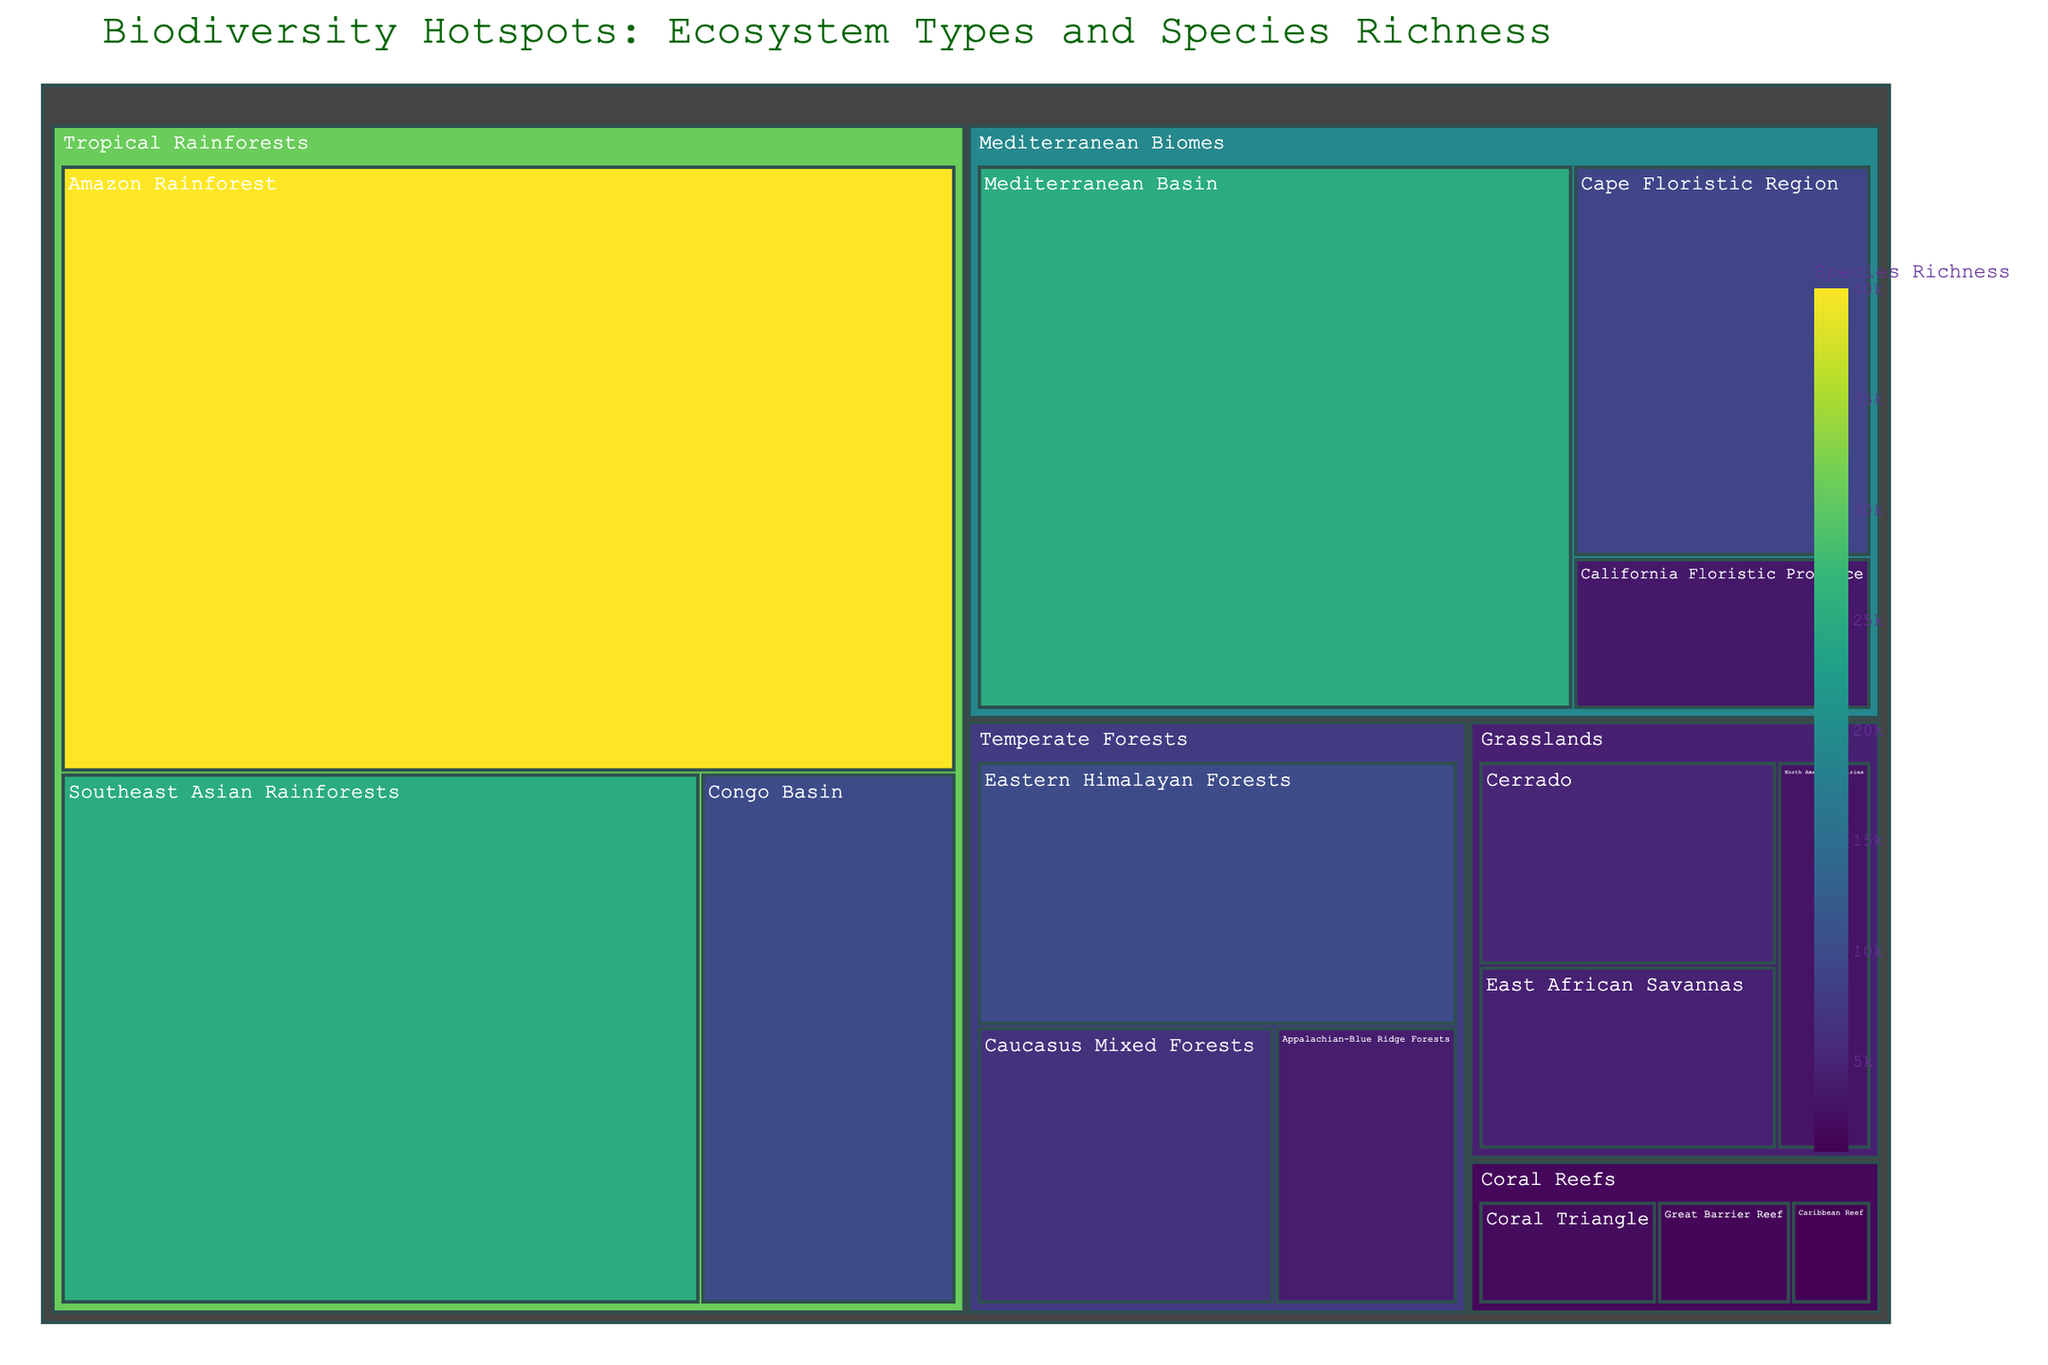Which ecosystem type has the highest species richness? By looking at the treemap, find the largest box under the "ecosystem" categories. The "Tropical Rainforests" category includes the Amazon Rainforest with 40,000 species of richness, the highest value for any ecosystem type.
Answer: Tropical Rainforests Which forest type within the Temperate Forests has the lowest species richness? Locate the "Temperate Forests" section in the treemap and find the box with the smallest value. The Appalachian-Blue Ridge Forests has the lowest species richness with 4000 species.
Answer: Appalachian-Blue Ridge Forests What is the combined species richness of the Coral Reefs ecosystems? Add the species richness of all Coral Reefs: Great Barrier Reef (1500) + Coral Triangle (2000) + Caribbean Reef (900) = 4400 species.
Answer: 4400 species Which has higher species richness: the Mediterranean Basin or the entire Grasslands ecosystem type? Compare the species richness of the Mediterranean Basin (25000) with the sum of all Grasslands: Cerrado (5000) + East African Savannas (4500) + North American Prairies (3000) = 12500. The Mediterranean Basin has a higher count.
Answer: Mediterranean Basin Among the Mediterranean Biomes, which floristic region has the highest species richness? Within the "Mediterranean Biomes", the Mediterranean Basin has the highest species richness at 25000 compared to California Floristic Province and Cape Floristic Region.
Answer: Mediterranean Basin How much more species-rich is the Amazon Rainforest compared to the entire Temperate Forests ecosystem type? Subtract the combined species richness of Temperate Forests: Eastern Himalayan Forests (10000) + Appalachian-Blue Ridge Forests (4000) + Caucasus Mixed Forests (6500) = 20500, from the Amazon Rainforest's 40000 species. The difference is 40000 - 20500 = 19500 species.
Answer: 19500 species What is the average species richness across all Tropical Rainforests? Calculate the average species richness for Tropical Rainforests by summing the species of Amazon Rainforest (40000), Congo Basin (10000), and Southeast Asian Rainforests (25000), and dividing by 3. (40000 + 10000 + 25000) / 3 = 25000 species.
Answer: 25000 species Which region within Grasslands has the highest species richness? Look within the "Grasslands" category in the treemap and find the highest value. Cerrado has the highest species richness at 5000.
Answer: Cerrado 